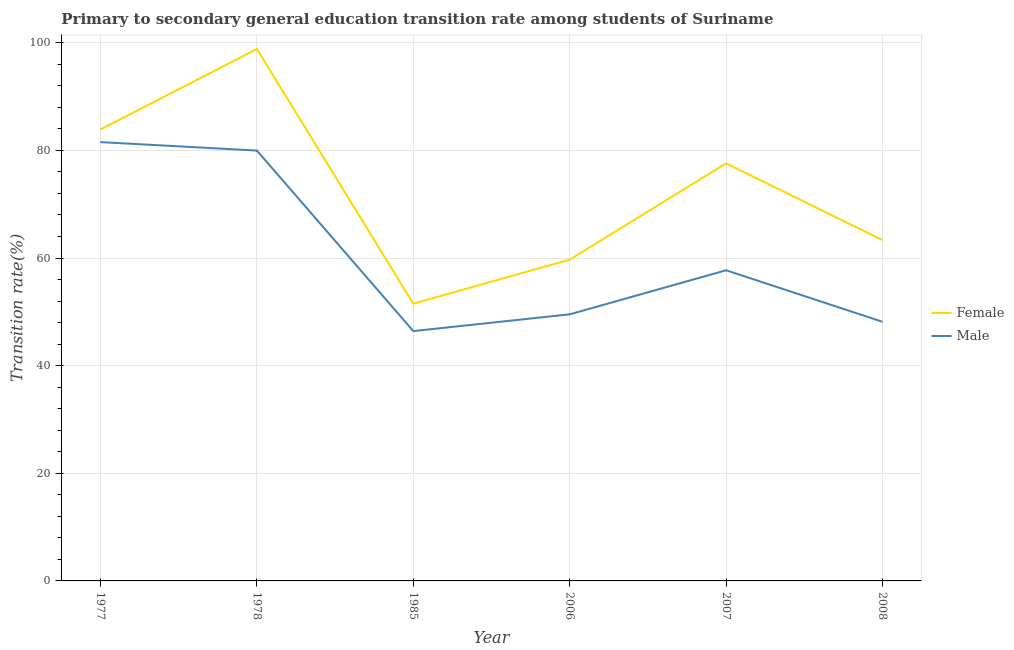What is the transition rate among male students in 2008?
Offer a very short reply. 48.15. Across all years, what is the maximum transition rate among male students?
Provide a succinct answer. 81.54. Across all years, what is the minimum transition rate among male students?
Your answer should be compact. 46.42. In which year was the transition rate among male students minimum?
Give a very brief answer. 1985. What is the total transition rate among female students in the graph?
Offer a terse response. 434.86. What is the difference between the transition rate among male students in 1977 and that in 2008?
Your response must be concise. 33.39. What is the difference between the transition rate among female students in 1978 and the transition rate among male students in 2008?
Keep it short and to the point. 50.69. What is the average transition rate among female students per year?
Provide a short and direct response. 72.48. In the year 2007, what is the difference between the transition rate among female students and transition rate among male students?
Keep it short and to the point. 19.86. What is the ratio of the transition rate among male students in 1985 to that in 2006?
Your answer should be compact. 0.94. Is the difference between the transition rate among male students in 1977 and 1978 greater than the difference between the transition rate among female students in 1977 and 1978?
Provide a short and direct response. Yes. What is the difference between the highest and the second highest transition rate among male students?
Offer a very short reply. 1.57. What is the difference between the highest and the lowest transition rate among male students?
Your answer should be compact. 35.11. In how many years, is the transition rate among male students greater than the average transition rate among male students taken over all years?
Offer a terse response. 2. Is the sum of the transition rate among female students in 1977 and 2007 greater than the maximum transition rate among male students across all years?
Offer a terse response. Yes. Does the transition rate among female students monotonically increase over the years?
Give a very brief answer. No. Is the transition rate among male students strictly greater than the transition rate among female students over the years?
Offer a very short reply. No. How many lines are there?
Ensure brevity in your answer.  2. Are the values on the major ticks of Y-axis written in scientific E-notation?
Ensure brevity in your answer.  No. Does the graph contain any zero values?
Ensure brevity in your answer.  No. How many legend labels are there?
Ensure brevity in your answer.  2. How are the legend labels stacked?
Ensure brevity in your answer.  Vertical. What is the title of the graph?
Provide a short and direct response. Primary to secondary general education transition rate among students of Suriname. Does "Under five" appear as one of the legend labels in the graph?
Give a very brief answer. No. What is the label or title of the Y-axis?
Give a very brief answer. Transition rate(%). What is the Transition rate(%) in Female in 1977?
Make the answer very short. 83.89. What is the Transition rate(%) in Male in 1977?
Give a very brief answer. 81.54. What is the Transition rate(%) in Female in 1978?
Offer a terse response. 98.84. What is the Transition rate(%) of Male in 1978?
Make the answer very short. 79.97. What is the Transition rate(%) in Female in 1985?
Ensure brevity in your answer.  51.52. What is the Transition rate(%) of Male in 1985?
Offer a very short reply. 46.42. What is the Transition rate(%) of Female in 2006?
Provide a short and direct response. 59.7. What is the Transition rate(%) of Male in 2006?
Offer a very short reply. 49.53. What is the Transition rate(%) in Female in 2007?
Give a very brief answer. 77.59. What is the Transition rate(%) of Male in 2007?
Give a very brief answer. 57.72. What is the Transition rate(%) of Female in 2008?
Your answer should be very brief. 63.33. What is the Transition rate(%) of Male in 2008?
Make the answer very short. 48.15. Across all years, what is the maximum Transition rate(%) in Female?
Your answer should be very brief. 98.84. Across all years, what is the maximum Transition rate(%) in Male?
Your response must be concise. 81.54. Across all years, what is the minimum Transition rate(%) of Female?
Keep it short and to the point. 51.52. Across all years, what is the minimum Transition rate(%) of Male?
Provide a short and direct response. 46.42. What is the total Transition rate(%) of Female in the graph?
Keep it short and to the point. 434.86. What is the total Transition rate(%) of Male in the graph?
Make the answer very short. 363.33. What is the difference between the Transition rate(%) of Female in 1977 and that in 1978?
Offer a terse response. -14.95. What is the difference between the Transition rate(%) of Male in 1977 and that in 1978?
Offer a very short reply. 1.57. What is the difference between the Transition rate(%) in Female in 1977 and that in 1985?
Offer a terse response. 32.37. What is the difference between the Transition rate(%) in Male in 1977 and that in 1985?
Keep it short and to the point. 35.11. What is the difference between the Transition rate(%) of Female in 1977 and that in 2006?
Offer a terse response. 24.18. What is the difference between the Transition rate(%) in Male in 1977 and that in 2006?
Your answer should be compact. 32. What is the difference between the Transition rate(%) in Female in 1977 and that in 2007?
Provide a succinct answer. 6.3. What is the difference between the Transition rate(%) of Male in 1977 and that in 2007?
Ensure brevity in your answer.  23.81. What is the difference between the Transition rate(%) of Female in 1977 and that in 2008?
Your answer should be very brief. 20.56. What is the difference between the Transition rate(%) in Male in 1977 and that in 2008?
Keep it short and to the point. 33.39. What is the difference between the Transition rate(%) of Female in 1978 and that in 1985?
Make the answer very short. 47.33. What is the difference between the Transition rate(%) of Male in 1978 and that in 1985?
Keep it short and to the point. 33.54. What is the difference between the Transition rate(%) in Female in 1978 and that in 2006?
Offer a very short reply. 39.14. What is the difference between the Transition rate(%) of Male in 1978 and that in 2006?
Your answer should be compact. 30.43. What is the difference between the Transition rate(%) of Female in 1978 and that in 2007?
Your answer should be compact. 21.25. What is the difference between the Transition rate(%) of Male in 1978 and that in 2007?
Ensure brevity in your answer.  22.24. What is the difference between the Transition rate(%) in Female in 1978 and that in 2008?
Ensure brevity in your answer.  35.52. What is the difference between the Transition rate(%) in Male in 1978 and that in 2008?
Offer a terse response. 31.82. What is the difference between the Transition rate(%) in Female in 1985 and that in 2006?
Keep it short and to the point. -8.19. What is the difference between the Transition rate(%) in Male in 1985 and that in 2006?
Ensure brevity in your answer.  -3.11. What is the difference between the Transition rate(%) of Female in 1985 and that in 2007?
Ensure brevity in your answer.  -26.07. What is the difference between the Transition rate(%) in Male in 1985 and that in 2007?
Give a very brief answer. -11.3. What is the difference between the Transition rate(%) of Female in 1985 and that in 2008?
Offer a terse response. -11.81. What is the difference between the Transition rate(%) of Male in 1985 and that in 2008?
Give a very brief answer. -1.73. What is the difference between the Transition rate(%) of Female in 2006 and that in 2007?
Offer a terse response. -17.88. What is the difference between the Transition rate(%) of Male in 2006 and that in 2007?
Your answer should be compact. -8.19. What is the difference between the Transition rate(%) in Female in 2006 and that in 2008?
Your answer should be very brief. -3.62. What is the difference between the Transition rate(%) in Male in 2006 and that in 2008?
Your answer should be very brief. 1.38. What is the difference between the Transition rate(%) of Female in 2007 and that in 2008?
Provide a succinct answer. 14.26. What is the difference between the Transition rate(%) in Male in 2007 and that in 2008?
Make the answer very short. 9.57. What is the difference between the Transition rate(%) in Female in 1977 and the Transition rate(%) in Male in 1978?
Provide a succinct answer. 3.92. What is the difference between the Transition rate(%) in Female in 1977 and the Transition rate(%) in Male in 1985?
Your answer should be compact. 37.46. What is the difference between the Transition rate(%) of Female in 1977 and the Transition rate(%) of Male in 2006?
Offer a very short reply. 34.35. What is the difference between the Transition rate(%) in Female in 1977 and the Transition rate(%) in Male in 2007?
Give a very brief answer. 26.16. What is the difference between the Transition rate(%) in Female in 1977 and the Transition rate(%) in Male in 2008?
Provide a short and direct response. 35.74. What is the difference between the Transition rate(%) in Female in 1978 and the Transition rate(%) in Male in 1985?
Your response must be concise. 52.42. What is the difference between the Transition rate(%) in Female in 1978 and the Transition rate(%) in Male in 2006?
Ensure brevity in your answer.  49.31. What is the difference between the Transition rate(%) of Female in 1978 and the Transition rate(%) of Male in 2007?
Your response must be concise. 41.12. What is the difference between the Transition rate(%) of Female in 1978 and the Transition rate(%) of Male in 2008?
Your response must be concise. 50.69. What is the difference between the Transition rate(%) in Female in 1985 and the Transition rate(%) in Male in 2006?
Give a very brief answer. 1.98. What is the difference between the Transition rate(%) of Female in 1985 and the Transition rate(%) of Male in 2007?
Offer a very short reply. -6.21. What is the difference between the Transition rate(%) in Female in 1985 and the Transition rate(%) in Male in 2008?
Provide a succinct answer. 3.37. What is the difference between the Transition rate(%) of Female in 2006 and the Transition rate(%) of Male in 2007?
Your response must be concise. 1.98. What is the difference between the Transition rate(%) of Female in 2006 and the Transition rate(%) of Male in 2008?
Offer a very short reply. 11.55. What is the difference between the Transition rate(%) of Female in 2007 and the Transition rate(%) of Male in 2008?
Provide a succinct answer. 29.44. What is the average Transition rate(%) in Female per year?
Provide a short and direct response. 72.48. What is the average Transition rate(%) in Male per year?
Provide a succinct answer. 60.56. In the year 1977, what is the difference between the Transition rate(%) of Female and Transition rate(%) of Male?
Give a very brief answer. 2.35. In the year 1978, what is the difference between the Transition rate(%) of Female and Transition rate(%) of Male?
Offer a very short reply. 18.87. In the year 1985, what is the difference between the Transition rate(%) in Female and Transition rate(%) in Male?
Make the answer very short. 5.09. In the year 2006, what is the difference between the Transition rate(%) of Female and Transition rate(%) of Male?
Your answer should be compact. 10.17. In the year 2007, what is the difference between the Transition rate(%) of Female and Transition rate(%) of Male?
Keep it short and to the point. 19.86. In the year 2008, what is the difference between the Transition rate(%) of Female and Transition rate(%) of Male?
Ensure brevity in your answer.  15.18. What is the ratio of the Transition rate(%) in Female in 1977 to that in 1978?
Ensure brevity in your answer.  0.85. What is the ratio of the Transition rate(%) in Male in 1977 to that in 1978?
Offer a terse response. 1.02. What is the ratio of the Transition rate(%) of Female in 1977 to that in 1985?
Your answer should be compact. 1.63. What is the ratio of the Transition rate(%) in Male in 1977 to that in 1985?
Offer a terse response. 1.76. What is the ratio of the Transition rate(%) of Female in 1977 to that in 2006?
Your answer should be very brief. 1.41. What is the ratio of the Transition rate(%) of Male in 1977 to that in 2006?
Your answer should be very brief. 1.65. What is the ratio of the Transition rate(%) of Female in 1977 to that in 2007?
Offer a terse response. 1.08. What is the ratio of the Transition rate(%) of Male in 1977 to that in 2007?
Offer a very short reply. 1.41. What is the ratio of the Transition rate(%) of Female in 1977 to that in 2008?
Provide a succinct answer. 1.32. What is the ratio of the Transition rate(%) in Male in 1977 to that in 2008?
Offer a very short reply. 1.69. What is the ratio of the Transition rate(%) of Female in 1978 to that in 1985?
Provide a succinct answer. 1.92. What is the ratio of the Transition rate(%) in Male in 1978 to that in 1985?
Keep it short and to the point. 1.72. What is the ratio of the Transition rate(%) of Female in 1978 to that in 2006?
Provide a short and direct response. 1.66. What is the ratio of the Transition rate(%) in Male in 1978 to that in 2006?
Your answer should be very brief. 1.61. What is the ratio of the Transition rate(%) of Female in 1978 to that in 2007?
Give a very brief answer. 1.27. What is the ratio of the Transition rate(%) of Male in 1978 to that in 2007?
Your answer should be compact. 1.39. What is the ratio of the Transition rate(%) in Female in 1978 to that in 2008?
Provide a short and direct response. 1.56. What is the ratio of the Transition rate(%) of Male in 1978 to that in 2008?
Your answer should be compact. 1.66. What is the ratio of the Transition rate(%) in Female in 1985 to that in 2006?
Give a very brief answer. 0.86. What is the ratio of the Transition rate(%) of Male in 1985 to that in 2006?
Provide a succinct answer. 0.94. What is the ratio of the Transition rate(%) of Female in 1985 to that in 2007?
Keep it short and to the point. 0.66. What is the ratio of the Transition rate(%) of Male in 1985 to that in 2007?
Make the answer very short. 0.8. What is the ratio of the Transition rate(%) in Female in 1985 to that in 2008?
Your response must be concise. 0.81. What is the ratio of the Transition rate(%) in Male in 1985 to that in 2008?
Your response must be concise. 0.96. What is the ratio of the Transition rate(%) of Female in 2006 to that in 2007?
Your answer should be compact. 0.77. What is the ratio of the Transition rate(%) in Male in 2006 to that in 2007?
Make the answer very short. 0.86. What is the ratio of the Transition rate(%) in Female in 2006 to that in 2008?
Your response must be concise. 0.94. What is the ratio of the Transition rate(%) of Male in 2006 to that in 2008?
Your answer should be compact. 1.03. What is the ratio of the Transition rate(%) of Female in 2007 to that in 2008?
Keep it short and to the point. 1.23. What is the ratio of the Transition rate(%) in Male in 2007 to that in 2008?
Your answer should be compact. 1.2. What is the difference between the highest and the second highest Transition rate(%) of Female?
Ensure brevity in your answer.  14.95. What is the difference between the highest and the second highest Transition rate(%) of Male?
Make the answer very short. 1.57. What is the difference between the highest and the lowest Transition rate(%) of Female?
Your response must be concise. 47.33. What is the difference between the highest and the lowest Transition rate(%) of Male?
Keep it short and to the point. 35.11. 